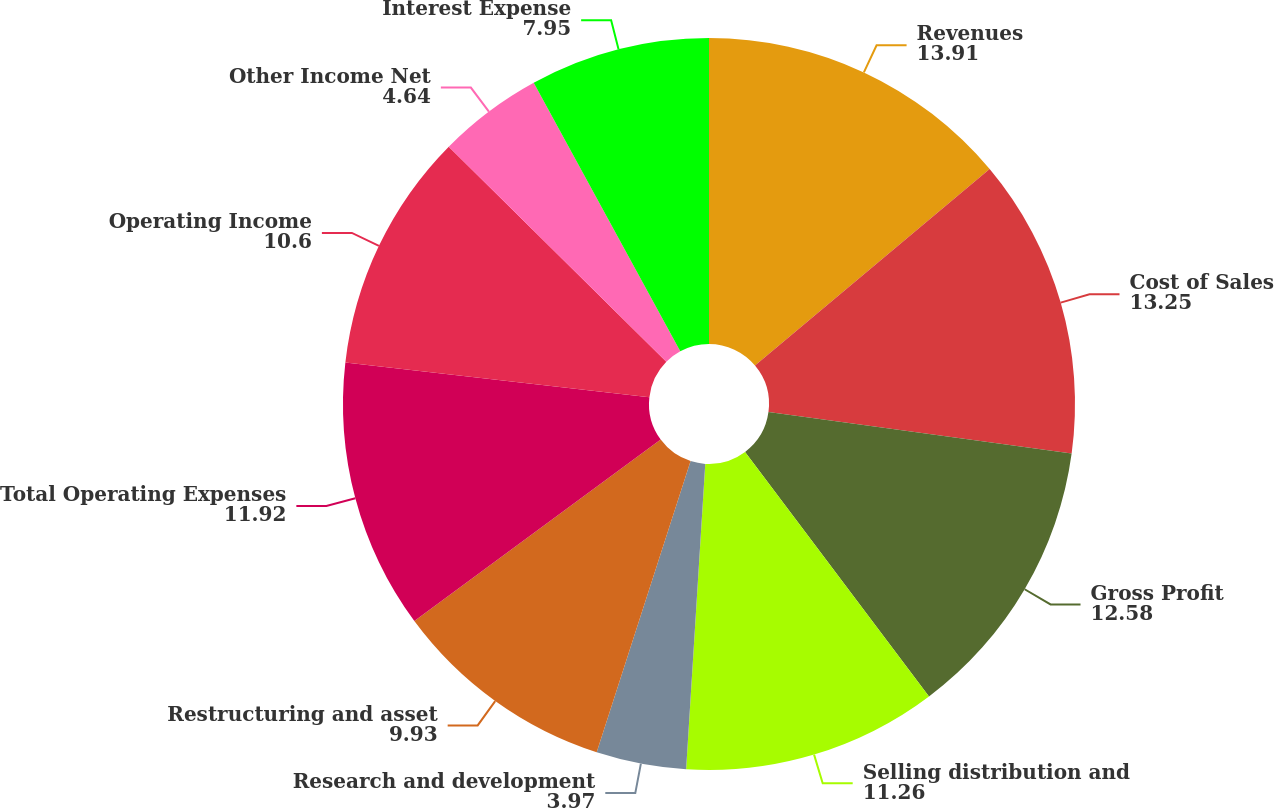<chart> <loc_0><loc_0><loc_500><loc_500><pie_chart><fcel>Revenues<fcel>Cost of Sales<fcel>Gross Profit<fcel>Selling distribution and<fcel>Research and development<fcel>Restructuring and asset<fcel>Total Operating Expenses<fcel>Operating Income<fcel>Other Income Net<fcel>Interest Expense<nl><fcel>13.91%<fcel>13.25%<fcel>12.58%<fcel>11.26%<fcel>3.97%<fcel>9.93%<fcel>11.92%<fcel>10.6%<fcel>4.64%<fcel>7.95%<nl></chart> 